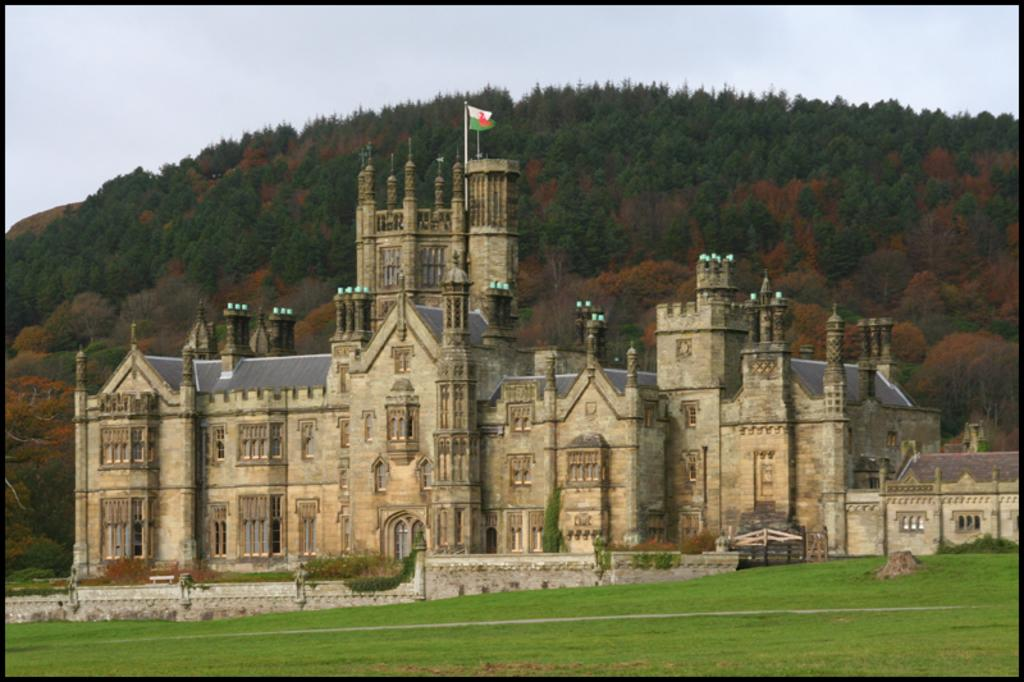What type of surface is visible on the ground in the image? There is grass on the ground in the image. What can be seen in the background of the image? There is a building, a flag, trees, and the sky visible in the background of the image. How many limits can be seen in the image? There are no limits visible in the image. What type of field is present in the image? There is no field present in the image. 